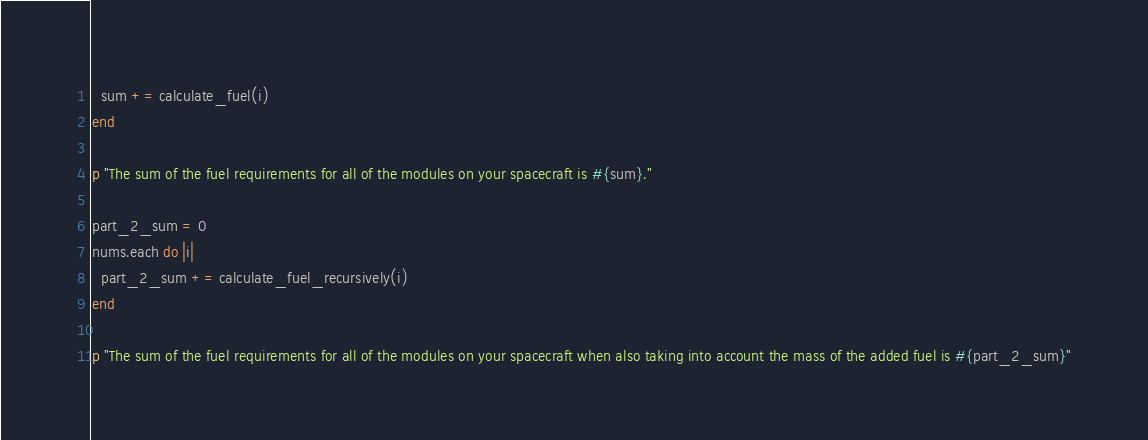Convert code to text. <code><loc_0><loc_0><loc_500><loc_500><_Crystal_>  sum += calculate_fuel(i)
end

p "The sum of the fuel requirements for all of the modules on your spacecraft is #{sum}."

part_2_sum = 0
nums.each do |i|
  part_2_sum += calculate_fuel_recursively(i)
end

p "The sum of the fuel requirements for all of the modules on your spacecraft when also taking into account the mass of the added fuel is #{part_2_sum}"
</code> 